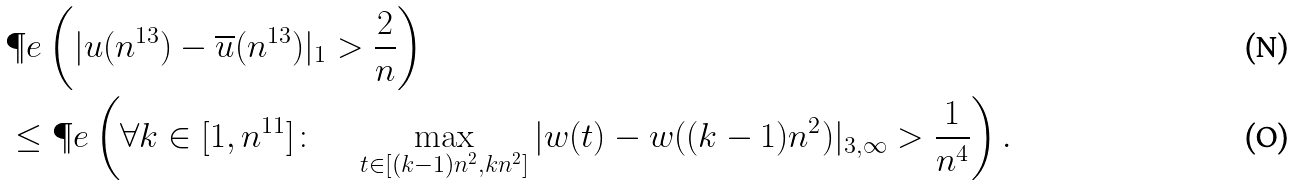<formula> <loc_0><loc_0><loc_500><loc_500>& \P e \left ( | u ( n ^ { 1 3 } ) - \overline { u } ( n ^ { 1 3 } ) | _ { 1 } > \frac { 2 } { n } \right ) \\ & \leq \P e \left ( \forall k \in [ 1 , n ^ { 1 1 } ] \colon \quad \max _ { t \in [ ( k - 1 ) n ^ { 2 } , k n ^ { 2 } ] } | w ( t ) - w ( ( k - 1 ) n ^ { 2 } ) | _ { 3 , \infty } > \frac { 1 } { n ^ { 4 } } \right ) .</formula> 